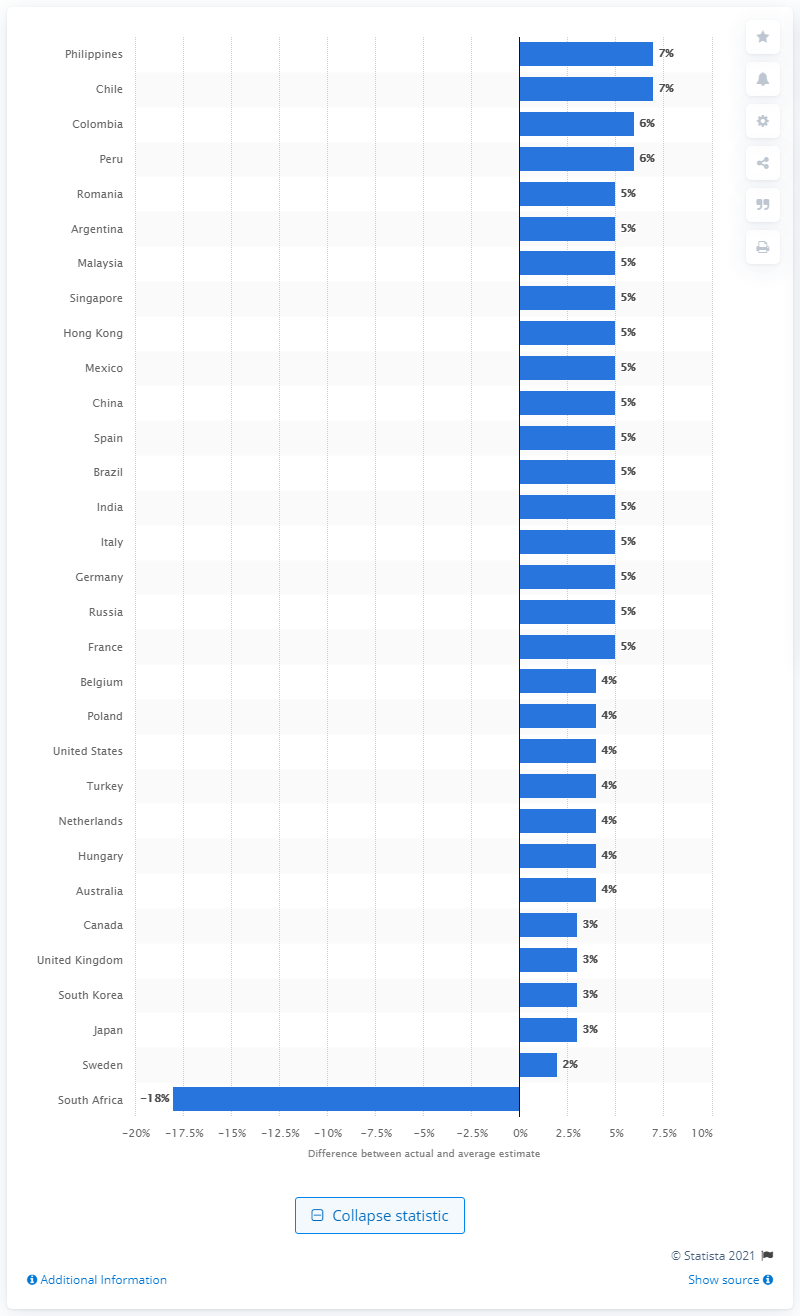Draw attention to some important aspects in this diagram. South Africa has the highest percentage of deaths due to HIV/AIDS and STIs among all countries. 